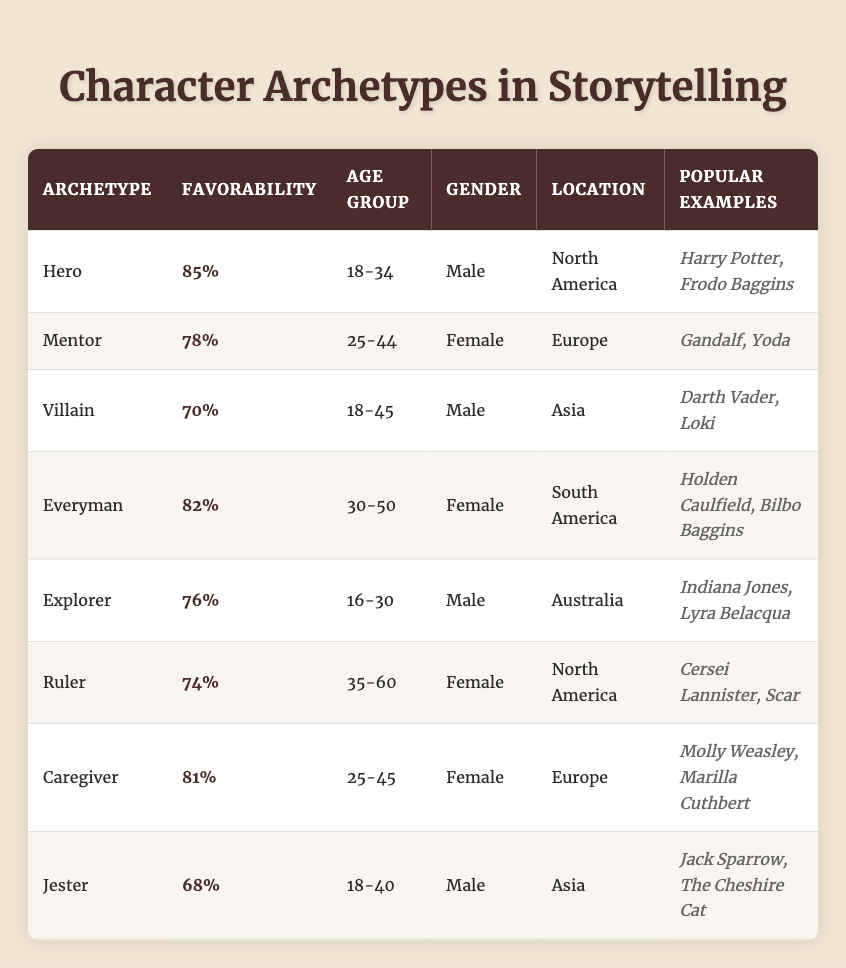What is the favorability percentage of the Hero archetype? The favorability percentage for the Hero archetype is shown directly in the table under the "Favorability" column next to "Hero," which lists it as 85%.
Answer: 85% How many popular examples are listed for the Villain archetype? The table indicates that under the "Popular Examples" column for the Villain archetype, there are two names provided: Darth Vader and Loki. Therefore, there are 2 examples listed.
Answer: 2 Which character archetype has the highest favorability percentage? The favorability percentages listed are: Hero (85%), Everyman (82%), Caregiver (81%), Mentor (78%), Explorer (76%), Ruler (74%), Villain (70%), and Jester (68%). By comparing these values, the Hero has the highest favorability at 85%.
Answer: Hero Is the Ruler archetype more favorable than the Explorer archetype? To determine this, we compare the favorability percentages of both. The Ruler's favorability is 74% while the Explorer's is 76%. Since 76% is greater than 74%, the statement is false.
Answer: No What is the average favorability percentage for all character archetypes listed? The favorability percentages are 85%, 78%, 70%, 82%, 76%, 74%, 81%, and 68%. Summing these gives: (85 + 78 + 70 + 82 + 76 + 74 + 81 + 68) = 614. There are 8 archetypes, so the average is 614/8 = 76.75.
Answer: 76.75 Which gender has a preference for the Mentor archetype? The table shows that under the "Gender" column for the Mentor archetype, it states "Female." Thus, the Mentor archetype is preferred by the Female gender.
Answer: Female Is there an character archetype among those listed that prefers an age group older than 50? Checking the age groups listed: Hero (18-34), Mentor (25-44), Villain (18-45), Everyman (30-50), Explorer (16-30), Ruler (35-60), Caregiver (25-45), and Jester (18-40). None of these groups exceed 50 years, making the fact false.
Answer: No What locations are associated with the highest and second-highest favored archetypes? The highest favored archetype is Hero from North America (85%), and the second-highest is Everyman from South America (82%). These locations are directly mentioned in the respective archetypes' rows.
Answer: North America; South America 